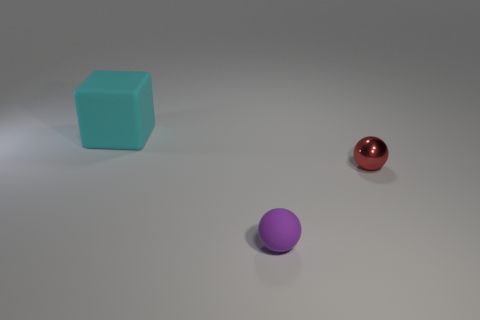Is there anything else that is the same size as the cyan matte cube?
Your answer should be compact. No. Is there anything else that has the same material as the red ball?
Make the answer very short. No. How many tiny purple matte objects are the same shape as the small red metallic object?
Offer a very short reply. 1. The cyan thing that is the same material as the tiny purple thing is what size?
Provide a succinct answer. Large. What color is the thing that is left of the small red thing and in front of the cyan rubber block?
Offer a terse response. Purple. How many gray metal cylinders have the same size as the metal ball?
Provide a short and direct response. 0. There is a object that is both to the right of the large object and behind the tiny purple matte sphere; what is its size?
Give a very brief answer. Small. What number of tiny matte balls are right of the ball right of the tiny ball that is on the left side of the metal object?
Offer a terse response. 0. Are there any metal things that have the same color as the large matte thing?
Provide a short and direct response. No. The matte sphere that is the same size as the shiny thing is what color?
Keep it short and to the point. Purple. 